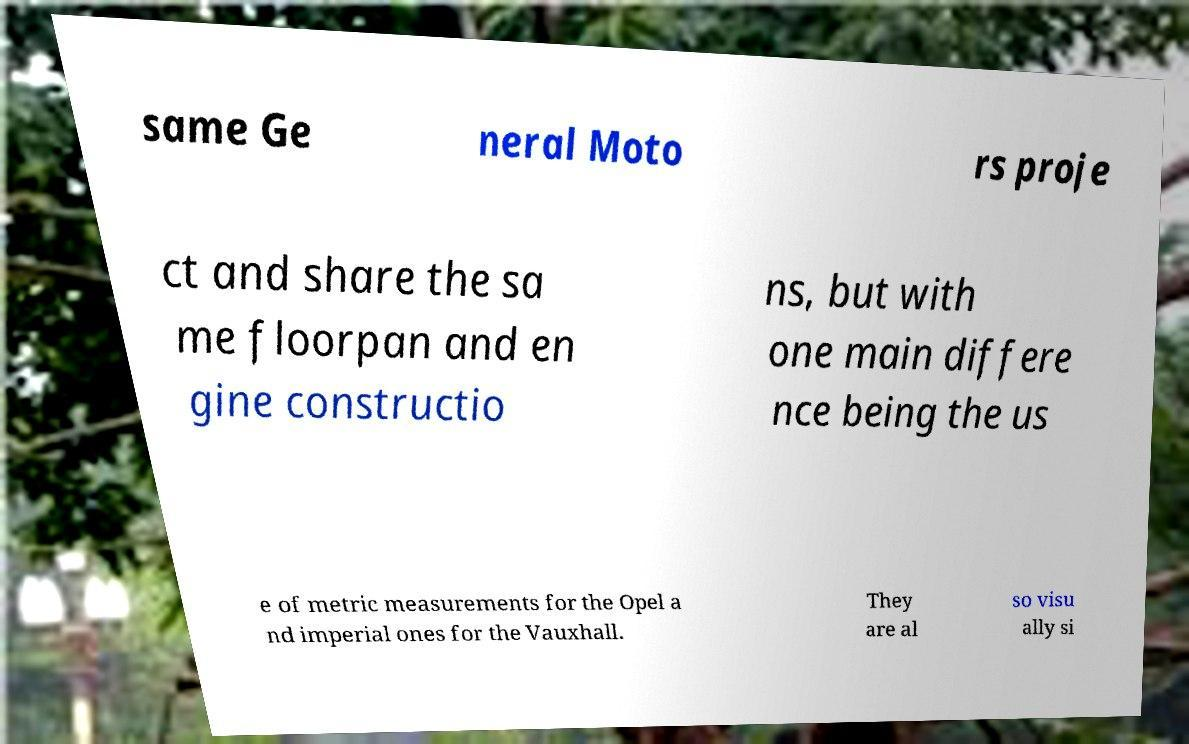Can you read and provide the text displayed in the image?This photo seems to have some interesting text. Can you extract and type it out for me? same Ge neral Moto rs proje ct and share the sa me floorpan and en gine constructio ns, but with one main differe nce being the us e of metric measurements for the Opel a nd imperial ones for the Vauxhall. They are al so visu ally si 